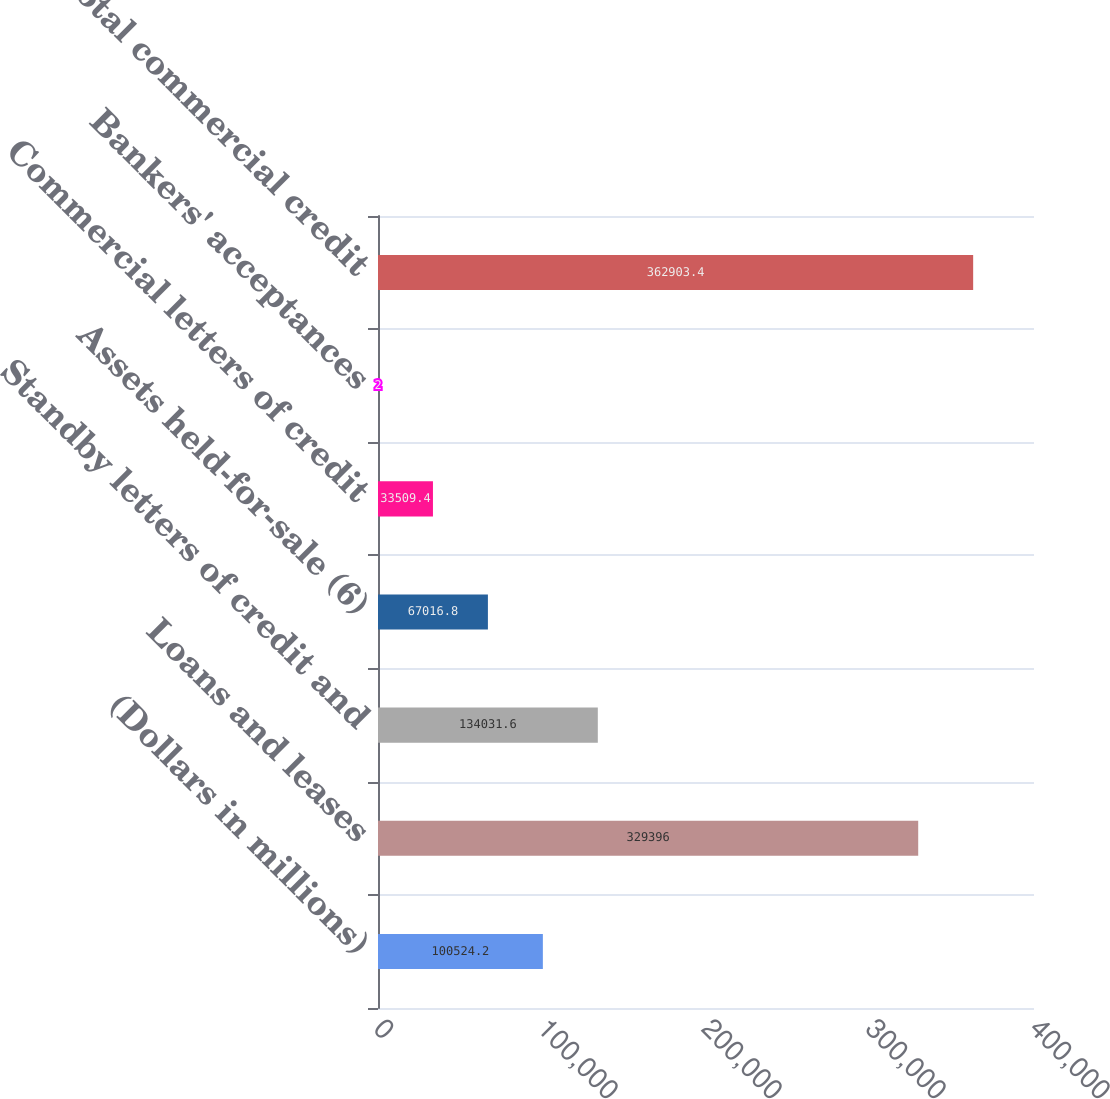Convert chart to OTSL. <chart><loc_0><loc_0><loc_500><loc_500><bar_chart><fcel>(Dollars in millions)<fcel>Loans and leases<fcel>Standby letters of credit and<fcel>Assets held-for-sale (6)<fcel>Commercial letters of credit<fcel>Bankers' acceptances<fcel>Total commercial credit<nl><fcel>100524<fcel>329396<fcel>134032<fcel>67016.8<fcel>33509.4<fcel>2<fcel>362903<nl></chart> 